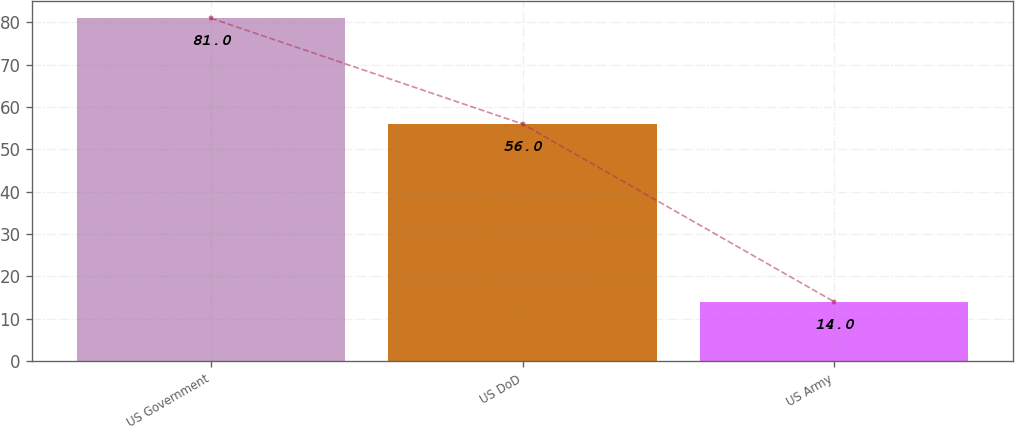<chart> <loc_0><loc_0><loc_500><loc_500><bar_chart><fcel>US Government<fcel>US DoD<fcel>US Army<nl><fcel>81<fcel>56<fcel>14<nl></chart> 